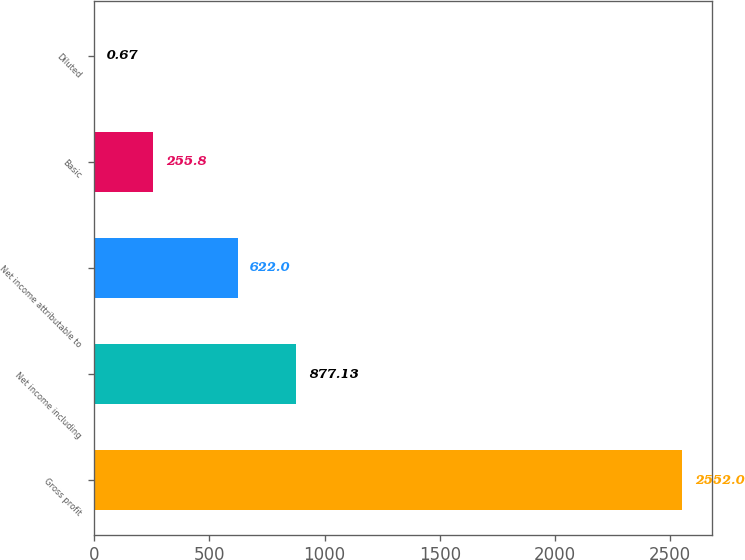<chart> <loc_0><loc_0><loc_500><loc_500><bar_chart><fcel>Gross profit<fcel>Net income including<fcel>Net income attributable to<fcel>Basic<fcel>Diluted<nl><fcel>2552<fcel>877.13<fcel>622<fcel>255.8<fcel>0.67<nl></chart> 